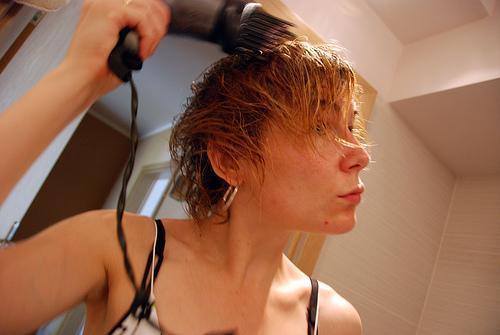How many people are in this picture?
Give a very brief answer. 1. 